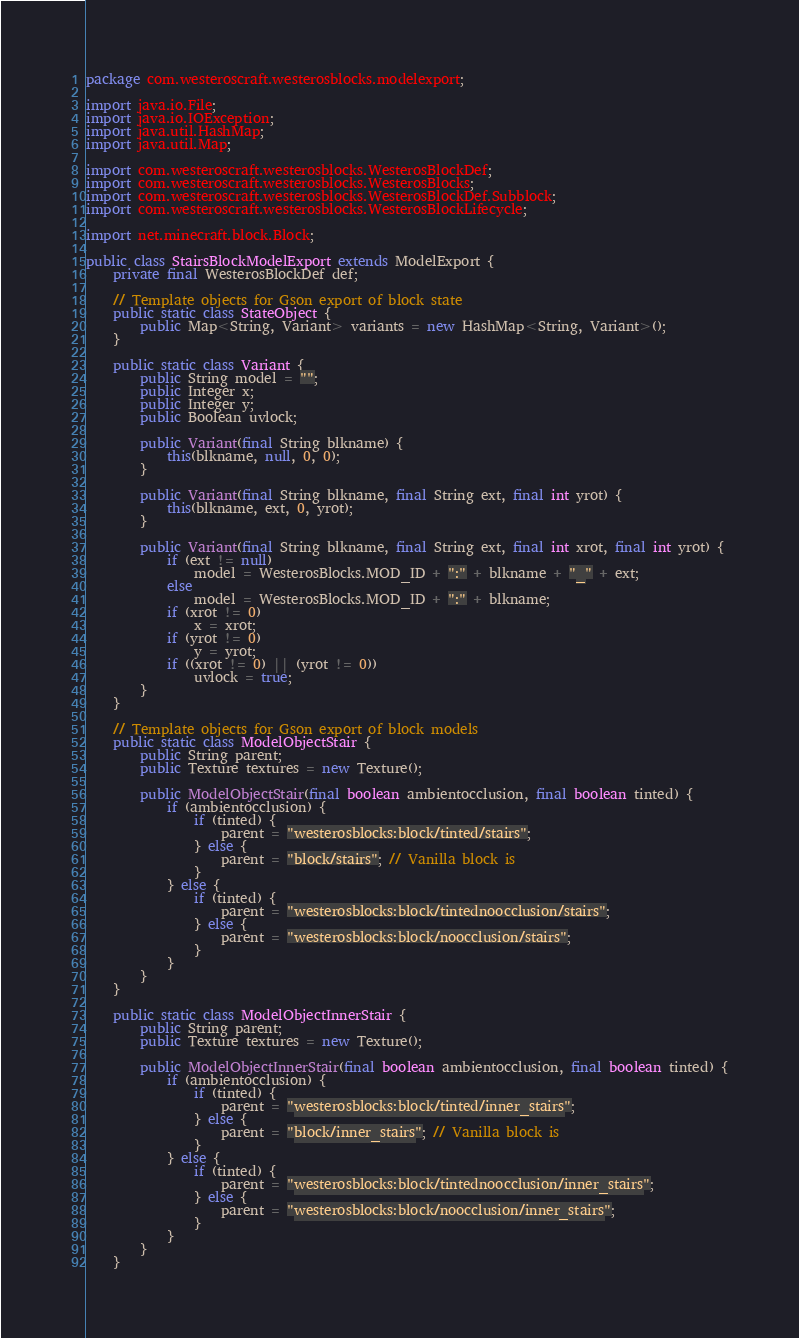<code> <loc_0><loc_0><loc_500><loc_500><_Java_>package com.westeroscraft.westerosblocks.modelexport;

import java.io.File;
import java.io.IOException;
import java.util.HashMap;
import java.util.Map;

import com.westeroscraft.westerosblocks.WesterosBlockDef;
import com.westeroscraft.westerosblocks.WesterosBlocks;
import com.westeroscraft.westerosblocks.WesterosBlockDef.Subblock;
import com.westeroscraft.westerosblocks.WesterosBlockLifecycle;

import net.minecraft.block.Block;

public class StairsBlockModelExport extends ModelExport {
    private final WesterosBlockDef def;

    // Template objects for Gson export of block state
    public static class StateObject {
        public Map<String, Variant> variants = new HashMap<String, Variant>();
    }

    public static class Variant {
        public String model = "";
        public Integer x;
        public Integer y;
        public Boolean uvlock;

        public Variant(final String blkname) {
            this(blkname, null, 0, 0);
        }

        public Variant(final String blkname, final String ext, final int yrot) {
            this(blkname, ext, 0, yrot);
        }

        public Variant(final String blkname, final String ext, final int xrot, final int yrot) {
            if (ext != null)
                model = WesterosBlocks.MOD_ID + ":" + blkname + "_" + ext;
            else
                model = WesterosBlocks.MOD_ID + ":" + blkname;
            if (xrot != 0)
                x = xrot;
            if (yrot != 0)
                y = yrot;
            if ((xrot != 0) || (yrot != 0))
                uvlock = true;
        }
    }

    // Template objects for Gson export of block models
    public static class ModelObjectStair {
        public String parent;
        public Texture textures = new Texture();

        public ModelObjectStair(final boolean ambientocclusion, final boolean tinted) {
            if (ambientocclusion) {
                if (tinted) {
                    parent = "westerosblocks:block/tinted/stairs";
                } else {
                    parent = "block/stairs"; // Vanilla block is
                }
            } else {
                if (tinted) {
                    parent = "westerosblocks:block/tintednoocclusion/stairs";
                } else {
                    parent = "westerosblocks:block/noocclusion/stairs";
                }
            }
        }
    }

    public static class ModelObjectInnerStair {
        public String parent;
        public Texture textures = new Texture();

        public ModelObjectInnerStair(final boolean ambientocclusion, final boolean tinted) {
            if (ambientocclusion) {
                if (tinted) {
                    parent = "westerosblocks:block/tinted/inner_stairs";
                } else {
                    parent = "block/inner_stairs"; // Vanilla block is
                }
            } else {
                if (tinted) {
                    parent = "westerosblocks:block/tintednoocclusion/inner_stairs";
                } else {
                    parent = "westerosblocks:block/noocclusion/inner_stairs";
                }
            }
        }
    }
</code> 